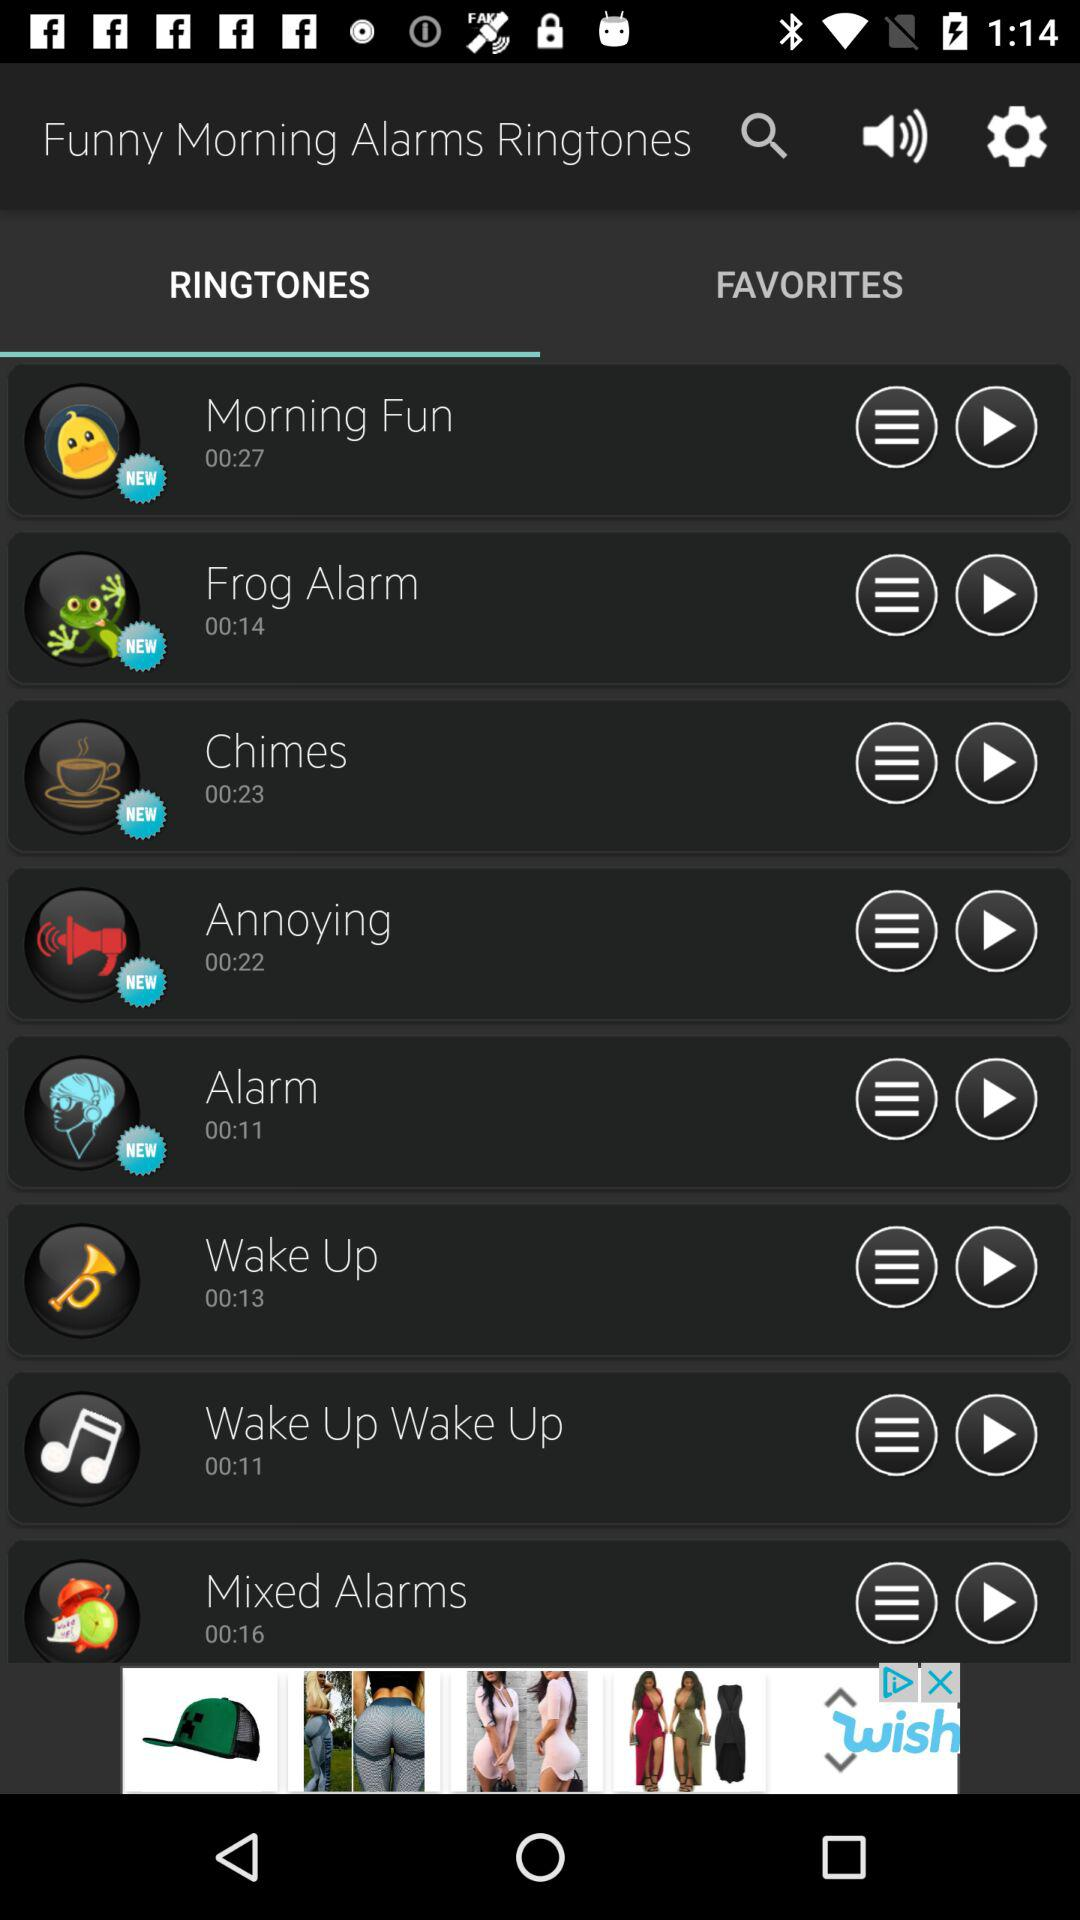What is the duration of "Morning Fun"? The duration is 27 seconds. 